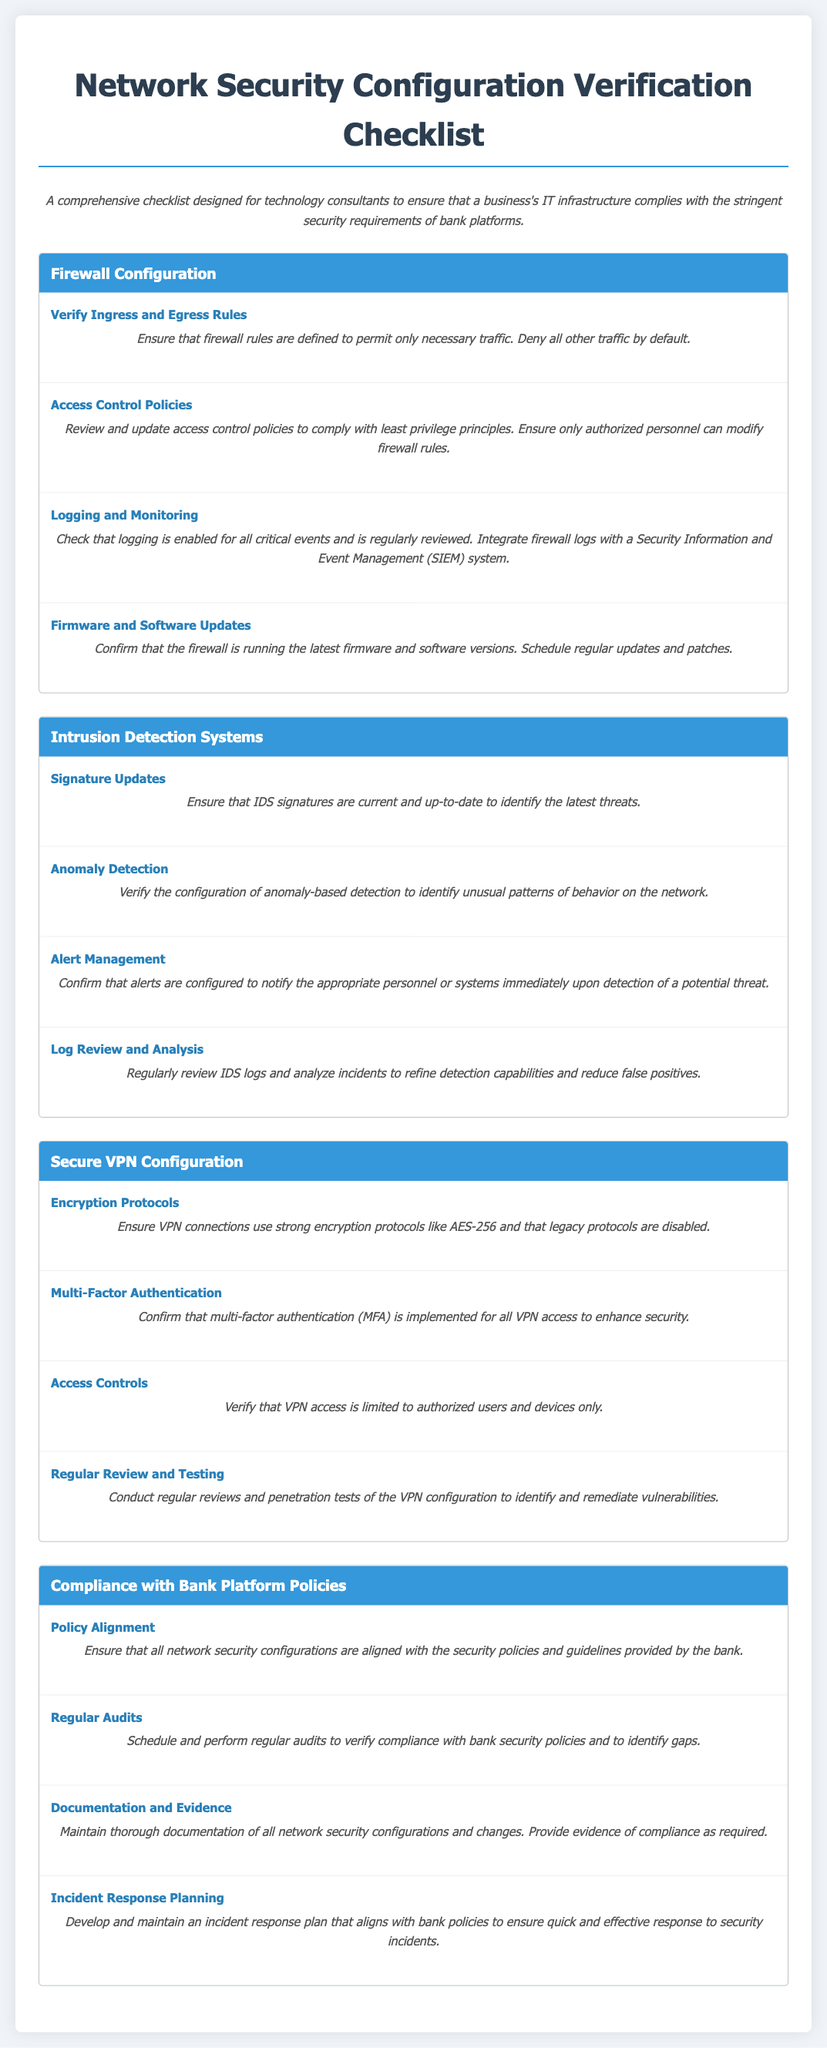What are the key components listed in the checklist? The key components in the checklist include Firewall Configuration, Intrusion Detection Systems, Secure VPN Configuration, and Compliance with Bank Platform Policies.
Answer: Firewall Configuration, Intrusion Detection Systems, Secure VPN Configuration, Compliance with Bank Platform Policies What encryption protocol should VPN connections use? The document specifies that VPN connections should use strong encryption protocols like AES-256.
Answer: AES-256 What is required for logging and monitoring in firewall configuration? The checklist states that logging must be enabled for all critical events and regularly reviewed, integrating with a SIEM system.
Answer: Enabled for all critical events and regularly reviewed How often should firmware and software updates be confirmed for firewalls? The checklist suggests confirming that the firewall is running the latest firmware and software versions and scheduling regular updates and patches.
Answer: Regular updates and patches What should be included in the incident response planning? According to the document, the incident response plan should align with bank policies to ensure quick and effective response to security incidents.
Answer: Align with bank policies What must be verified for VPN access controls? The checklist requires that VPN access be limited to authorized users and devices only.
Answer: Limited to authorized users and devices only When should regular audits be performed? The document mentions that regular audits should be scheduled to verify compliance with bank security policies and identify gaps.
Answer: Regularly What must be maintained for thorough documentation? The checklist states that thorough documentation of all network security configurations and changes must be maintained.
Answer: Thorough documentation of configurations and changes What is the purpose of anomaly detection in Intrusion Detection Systems? Anomaly detection is configured to identify unusual patterns of behavior on the network as per the checklist.
Answer: Identify unusual patterns of behavior 